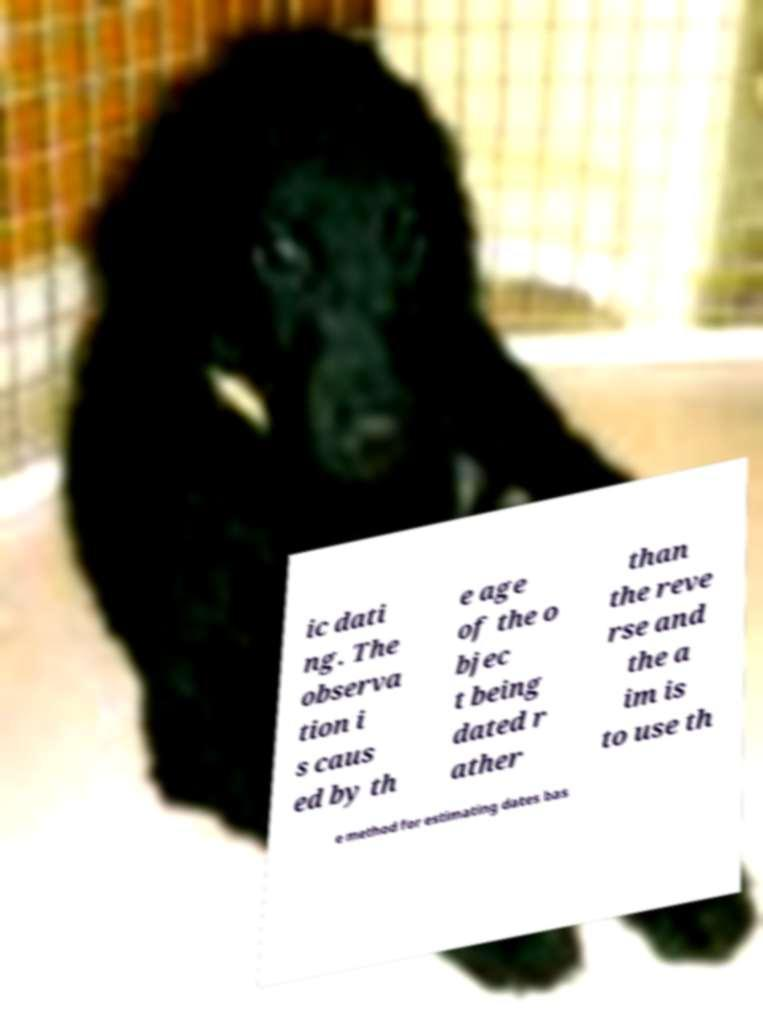There's text embedded in this image that I need extracted. Can you transcribe it verbatim? ic dati ng. The observa tion i s caus ed by th e age of the o bjec t being dated r ather than the reve rse and the a im is to use th e method for estimating dates bas 